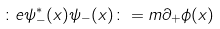<formula> <loc_0><loc_0><loc_500><loc_500>\colon e { \psi } _ { - } ^ { \ast } ( x ) \psi _ { - } ( x ) \colon = m { \partial } _ { + } { \phi } ( x )</formula> 